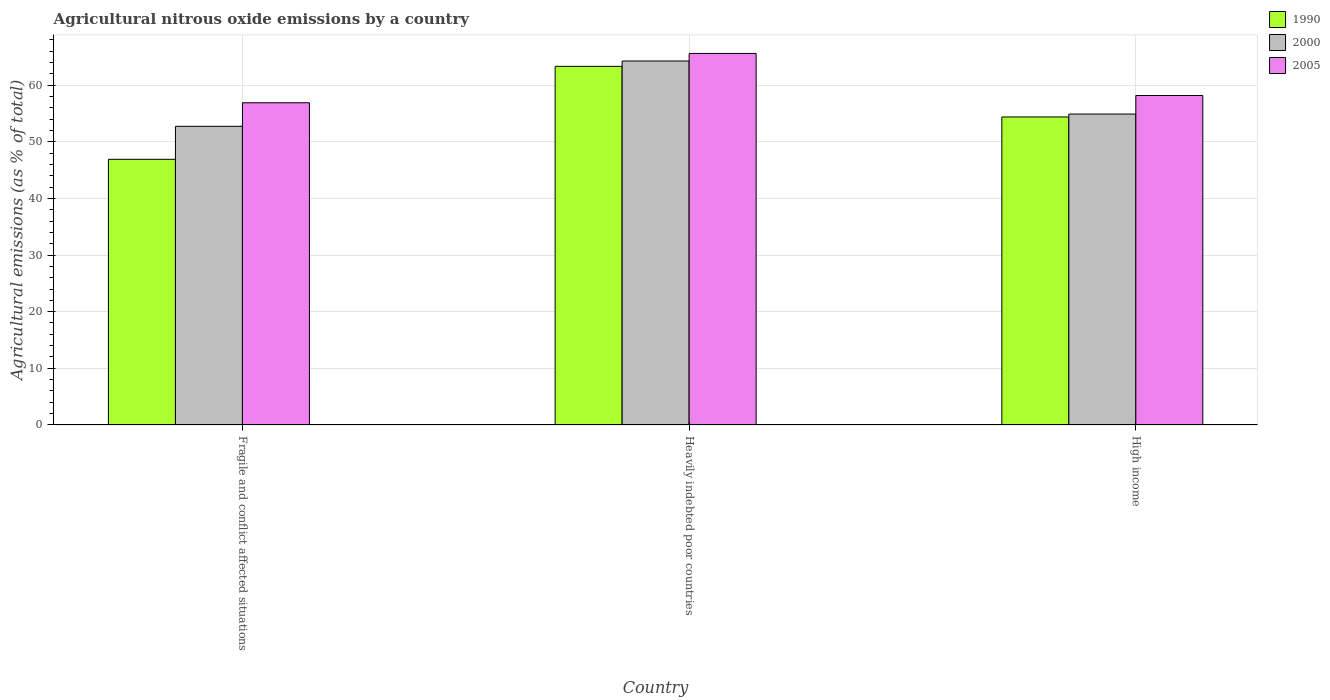How many groups of bars are there?
Ensure brevity in your answer.  3. Are the number of bars per tick equal to the number of legend labels?
Your answer should be compact. Yes. Are the number of bars on each tick of the X-axis equal?
Ensure brevity in your answer.  Yes. How many bars are there on the 3rd tick from the left?
Offer a very short reply. 3. How many bars are there on the 3rd tick from the right?
Provide a succinct answer. 3. What is the label of the 1st group of bars from the left?
Your response must be concise. Fragile and conflict affected situations. What is the amount of agricultural nitrous oxide emitted in 2000 in High income?
Provide a succinct answer. 54.91. Across all countries, what is the maximum amount of agricultural nitrous oxide emitted in 1990?
Offer a terse response. 63.33. Across all countries, what is the minimum amount of agricultural nitrous oxide emitted in 1990?
Your response must be concise. 46.91. In which country was the amount of agricultural nitrous oxide emitted in 2005 maximum?
Provide a succinct answer. Heavily indebted poor countries. In which country was the amount of agricultural nitrous oxide emitted in 2005 minimum?
Provide a succinct answer. Fragile and conflict affected situations. What is the total amount of agricultural nitrous oxide emitted in 2000 in the graph?
Your answer should be very brief. 171.92. What is the difference between the amount of agricultural nitrous oxide emitted in 2000 in Heavily indebted poor countries and that in High income?
Provide a succinct answer. 9.37. What is the difference between the amount of agricultural nitrous oxide emitted in 1990 in High income and the amount of agricultural nitrous oxide emitted in 2005 in Fragile and conflict affected situations?
Your response must be concise. -2.51. What is the average amount of agricultural nitrous oxide emitted in 2000 per country?
Provide a short and direct response. 57.31. What is the difference between the amount of agricultural nitrous oxide emitted of/in 2000 and amount of agricultural nitrous oxide emitted of/in 1990 in Fragile and conflict affected situations?
Provide a short and direct response. 5.83. What is the ratio of the amount of agricultural nitrous oxide emitted in 1990 in Heavily indebted poor countries to that in High income?
Provide a succinct answer. 1.16. Is the difference between the amount of agricultural nitrous oxide emitted in 2000 in Heavily indebted poor countries and High income greater than the difference between the amount of agricultural nitrous oxide emitted in 1990 in Heavily indebted poor countries and High income?
Offer a very short reply. Yes. What is the difference between the highest and the second highest amount of agricultural nitrous oxide emitted in 2005?
Provide a short and direct response. -8.71. What is the difference between the highest and the lowest amount of agricultural nitrous oxide emitted in 2005?
Ensure brevity in your answer.  8.71. What does the 1st bar from the left in High income represents?
Provide a short and direct response. 1990. How many bars are there?
Ensure brevity in your answer.  9. How many countries are there in the graph?
Make the answer very short. 3. Are the values on the major ticks of Y-axis written in scientific E-notation?
Your answer should be very brief. No. Does the graph contain grids?
Provide a succinct answer. Yes. Where does the legend appear in the graph?
Provide a short and direct response. Top right. How are the legend labels stacked?
Keep it short and to the point. Vertical. What is the title of the graph?
Make the answer very short. Agricultural nitrous oxide emissions by a country. What is the label or title of the Y-axis?
Keep it short and to the point. Agricultural emissions (as % of total). What is the Agricultural emissions (as % of total) in 1990 in Fragile and conflict affected situations?
Your answer should be compact. 46.91. What is the Agricultural emissions (as % of total) in 2000 in Fragile and conflict affected situations?
Ensure brevity in your answer.  52.74. What is the Agricultural emissions (as % of total) of 2005 in Fragile and conflict affected situations?
Offer a terse response. 56.9. What is the Agricultural emissions (as % of total) of 1990 in Heavily indebted poor countries?
Your answer should be very brief. 63.33. What is the Agricultural emissions (as % of total) of 2000 in Heavily indebted poor countries?
Your answer should be compact. 64.27. What is the Agricultural emissions (as % of total) of 2005 in Heavily indebted poor countries?
Offer a very short reply. 65.61. What is the Agricultural emissions (as % of total) in 1990 in High income?
Keep it short and to the point. 54.39. What is the Agricultural emissions (as % of total) in 2000 in High income?
Give a very brief answer. 54.91. What is the Agricultural emissions (as % of total) in 2005 in High income?
Give a very brief answer. 58.18. Across all countries, what is the maximum Agricultural emissions (as % of total) of 1990?
Keep it short and to the point. 63.33. Across all countries, what is the maximum Agricultural emissions (as % of total) in 2000?
Provide a short and direct response. 64.27. Across all countries, what is the maximum Agricultural emissions (as % of total) of 2005?
Your answer should be compact. 65.61. Across all countries, what is the minimum Agricultural emissions (as % of total) of 1990?
Keep it short and to the point. 46.91. Across all countries, what is the minimum Agricultural emissions (as % of total) in 2000?
Give a very brief answer. 52.74. Across all countries, what is the minimum Agricultural emissions (as % of total) of 2005?
Keep it short and to the point. 56.9. What is the total Agricultural emissions (as % of total) in 1990 in the graph?
Make the answer very short. 164.63. What is the total Agricultural emissions (as % of total) in 2000 in the graph?
Offer a very short reply. 171.92. What is the total Agricultural emissions (as % of total) of 2005 in the graph?
Offer a terse response. 180.68. What is the difference between the Agricultural emissions (as % of total) in 1990 in Fragile and conflict affected situations and that in Heavily indebted poor countries?
Your answer should be compact. -16.42. What is the difference between the Agricultural emissions (as % of total) in 2000 in Fragile and conflict affected situations and that in Heavily indebted poor countries?
Give a very brief answer. -11.53. What is the difference between the Agricultural emissions (as % of total) of 2005 in Fragile and conflict affected situations and that in Heavily indebted poor countries?
Provide a short and direct response. -8.71. What is the difference between the Agricultural emissions (as % of total) in 1990 in Fragile and conflict affected situations and that in High income?
Ensure brevity in your answer.  -7.48. What is the difference between the Agricultural emissions (as % of total) of 2000 in Fragile and conflict affected situations and that in High income?
Give a very brief answer. -2.17. What is the difference between the Agricultural emissions (as % of total) of 2005 in Fragile and conflict affected situations and that in High income?
Your response must be concise. -1.28. What is the difference between the Agricultural emissions (as % of total) in 1990 in Heavily indebted poor countries and that in High income?
Keep it short and to the point. 8.94. What is the difference between the Agricultural emissions (as % of total) of 2000 in Heavily indebted poor countries and that in High income?
Make the answer very short. 9.37. What is the difference between the Agricultural emissions (as % of total) of 2005 in Heavily indebted poor countries and that in High income?
Your answer should be compact. 7.43. What is the difference between the Agricultural emissions (as % of total) in 1990 in Fragile and conflict affected situations and the Agricultural emissions (as % of total) in 2000 in Heavily indebted poor countries?
Offer a terse response. -17.36. What is the difference between the Agricultural emissions (as % of total) in 1990 in Fragile and conflict affected situations and the Agricultural emissions (as % of total) in 2005 in Heavily indebted poor countries?
Offer a very short reply. -18.7. What is the difference between the Agricultural emissions (as % of total) in 2000 in Fragile and conflict affected situations and the Agricultural emissions (as % of total) in 2005 in Heavily indebted poor countries?
Your response must be concise. -12.87. What is the difference between the Agricultural emissions (as % of total) in 1990 in Fragile and conflict affected situations and the Agricultural emissions (as % of total) in 2000 in High income?
Ensure brevity in your answer.  -8. What is the difference between the Agricultural emissions (as % of total) of 1990 in Fragile and conflict affected situations and the Agricultural emissions (as % of total) of 2005 in High income?
Your answer should be very brief. -11.27. What is the difference between the Agricultural emissions (as % of total) in 2000 in Fragile and conflict affected situations and the Agricultural emissions (as % of total) in 2005 in High income?
Keep it short and to the point. -5.44. What is the difference between the Agricultural emissions (as % of total) of 1990 in Heavily indebted poor countries and the Agricultural emissions (as % of total) of 2000 in High income?
Your answer should be compact. 8.42. What is the difference between the Agricultural emissions (as % of total) of 1990 in Heavily indebted poor countries and the Agricultural emissions (as % of total) of 2005 in High income?
Offer a very short reply. 5.15. What is the difference between the Agricultural emissions (as % of total) of 2000 in Heavily indebted poor countries and the Agricultural emissions (as % of total) of 2005 in High income?
Your response must be concise. 6.09. What is the average Agricultural emissions (as % of total) in 1990 per country?
Provide a succinct answer. 54.88. What is the average Agricultural emissions (as % of total) of 2000 per country?
Make the answer very short. 57.31. What is the average Agricultural emissions (as % of total) of 2005 per country?
Provide a succinct answer. 60.23. What is the difference between the Agricultural emissions (as % of total) of 1990 and Agricultural emissions (as % of total) of 2000 in Fragile and conflict affected situations?
Offer a very short reply. -5.83. What is the difference between the Agricultural emissions (as % of total) of 1990 and Agricultural emissions (as % of total) of 2005 in Fragile and conflict affected situations?
Offer a very short reply. -9.99. What is the difference between the Agricultural emissions (as % of total) in 2000 and Agricultural emissions (as % of total) in 2005 in Fragile and conflict affected situations?
Keep it short and to the point. -4.16. What is the difference between the Agricultural emissions (as % of total) of 1990 and Agricultural emissions (as % of total) of 2000 in Heavily indebted poor countries?
Provide a succinct answer. -0.94. What is the difference between the Agricultural emissions (as % of total) in 1990 and Agricultural emissions (as % of total) in 2005 in Heavily indebted poor countries?
Your answer should be very brief. -2.28. What is the difference between the Agricultural emissions (as % of total) in 2000 and Agricultural emissions (as % of total) in 2005 in Heavily indebted poor countries?
Give a very brief answer. -1.33. What is the difference between the Agricultural emissions (as % of total) of 1990 and Agricultural emissions (as % of total) of 2000 in High income?
Provide a short and direct response. -0.52. What is the difference between the Agricultural emissions (as % of total) in 1990 and Agricultural emissions (as % of total) in 2005 in High income?
Your response must be concise. -3.79. What is the difference between the Agricultural emissions (as % of total) in 2000 and Agricultural emissions (as % of total) in 2005 in High income?
Offer a very short reply. -3.28. What is the ratio of the Agricultural emissions (as % of total) in 1990 in Fragile and conflict affected situations to that in Heavily indebted poor countries?
Ensure brevity in your answer.  0.74. What is the ratio of the Agricultural emissions (as % of total) in 2000 in Fragile and conflict affected situations to that in Heavily indebted poor countries?
Provide a succinct answer. 0.82. What is the ratio of the Agricultural emissions (as % of total) of 2005 in Fragile and conflict affected situations to that in Heavily indebted poor countries?
Offer a very short reply. 0.87. What is the ratio of the Agricultural emissions (as % of total) in 1990 in Fragile and conflict affected situations to that in High income?
Offer a terse response. 0.86. What is the ratio of the Agricultural emissions (as % of total) of 2000 in Fragile and conflict affected situations to that in High income?
Your response must be concise. 0.96. What is the ratio of the Agricultural emissions (as % of total) in 2005 in Fragile and conflict affected situations to that in High income?
Provide a short and direct response. 0.98. What is the ratio of the Agricultural emissions (as % of total) of 1990 in Heavily indebted poor countries to that in High income?
Offer a very short reply. 1.16. What is the ratio of the Agricultural emissions (as % of total) in 2000 in Heavily indebted poor countries to that in High income?
Keep it short and to the point. 1.17. What is the ratio of the Agricultural emissions (as % of total) in 2005 in Heavily indebted poor countries to that in High income?
Provide a short and direct response. 1.13. What is the difference between the highest and the second highest Agricultural emissions (as % of total) of 1990?
Offer a very short reply. 8.94. What is the difference between the highest and the second highest Agricultural emissions (as % of total) of 2000?
Your response must be concise. 9.37. What is the difference between the highest and the second highest Agricultural emissions (as % of total) in 2005?
Give a very brief answer. 7.43. What is the difference between the highest and the lowest Agricultural emissions (as % of total) in 1990?
Your answer should be very brief. 16.42. What is the difference between the highest and the lowest Agricultural emissions (as % of total) of 2000?
Offer a terse response. 11.53. What is the difference between the highest and the lowest Agricultural emissions (as % of total) of 2005?
Offer a terse response. 8.71. 